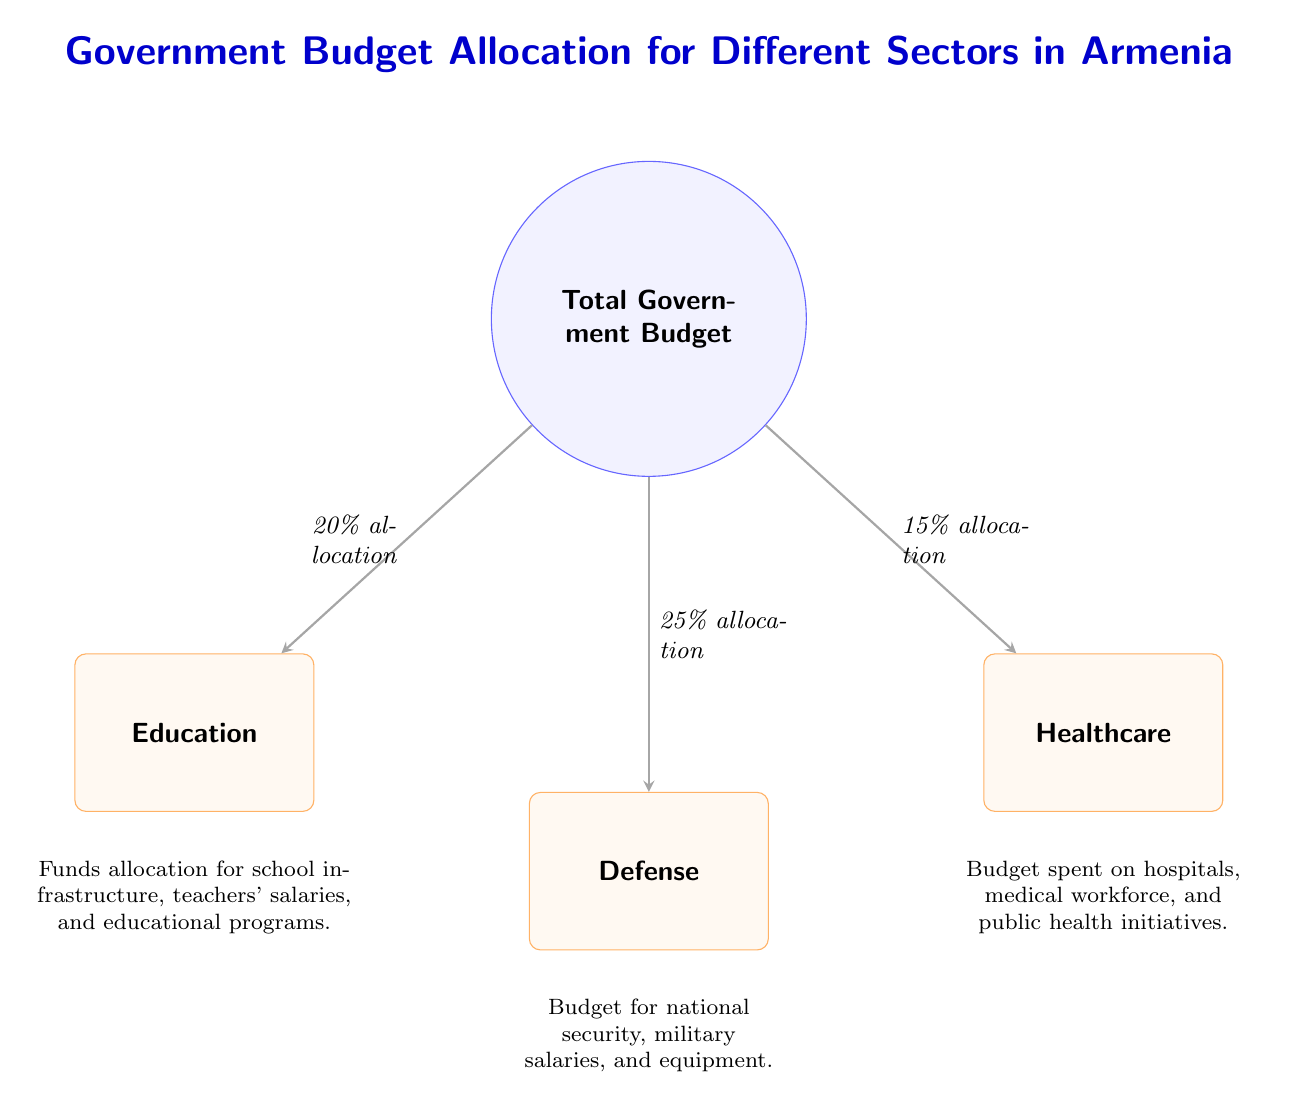What is the total percentage allocated to education? The diagram clearly shows that education receives a 20% allocation from the total government budget. This value is indicated on the arrow leading to the education node.
Answer: 20% What is the percentage of the budget allocated to defense? The defense node in the diagram states that it receives a 25% allocation, which is directly labeled on the connecting arrow.
Answer: 25% Which sector receives the least budget allocation? By comparing the percentages beside each sector, healthcare has the smallest allocation at 15%, indicated next to its node.
Answer: Healthcare How much of the total government budget is allocated to sectors other than education? To find this, we need to consider both defense and healthcare, which together account for 25% + 15% = 40% of the budget. Therefore, 100% - 40% equals 60%.
Answer: 60% What is the main purpose of the funds allocated to education? The description below the education node states that the funds are for school infrastructure, teachers' salaries, and educational programs. This indicates the focus of the budget allocation for that sector.
Answer: School infrastructure, teachers' salaries, and educational programs Which sector has the largest budget allocation? By examining the allocation percentages, defense at 25% is the highest compared to both education and healthcare, making it the sector with the largest budget share.
Answer: Defense What is the total percentage allocated to healthcare and defense combined? Adding the allocations for healthcare (15%) and defense (25%) gives a total of 40%. This is computed by direct addition of the percentages listed next to their respective nodes.
Answer: 40% How are the arrows used in the diagram? The arrows are used to indicate the flow of the budget from the total government budget node to the specific sector nodes, showing the percentage allocations for each sector.
Answer: To indicate budget flow and allocations 